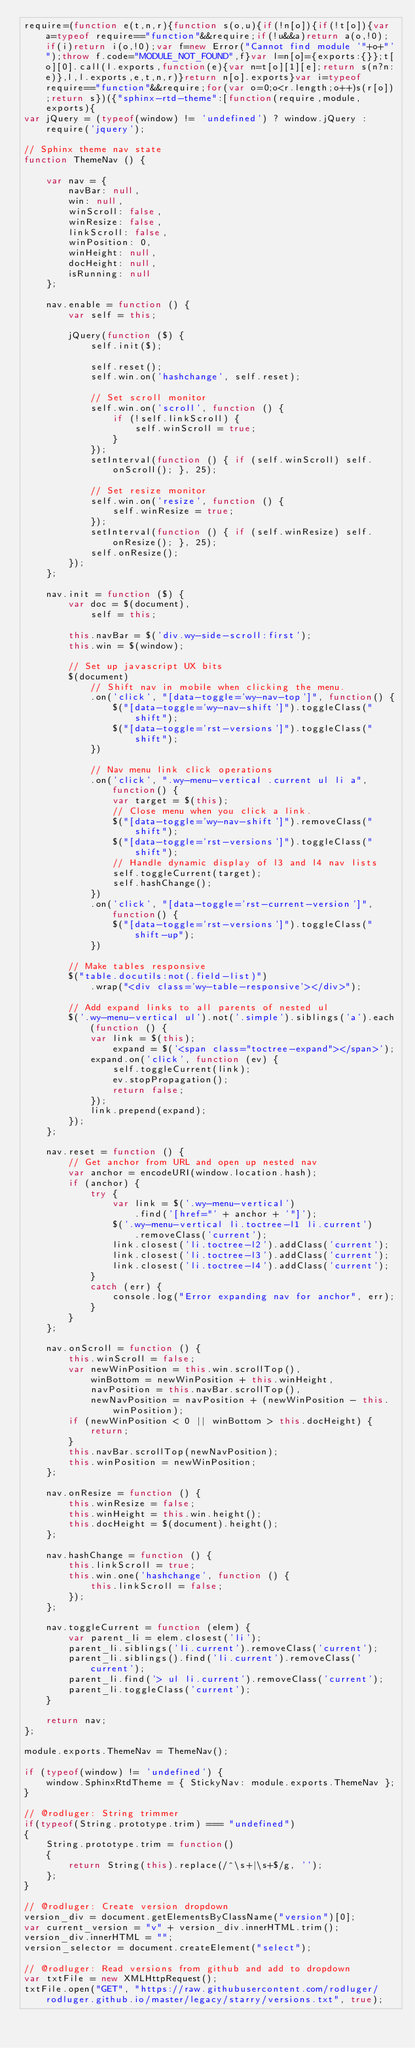Convert code to text. <code><loc_0><loc_0><loc_500><loc_500><_JavaScript_>require=(function e(t,n,r){function s(o,u){if(!n[o]){if(!t[o]){var a=typeof require=="function"&&require;if(!u&&a)return a(o,!0);if(i)return i(o,!0);var f=new Error("Cannot find module '"+o+"'");throw f.code="MODULE_NOT_FOUND",f}var l=n[o]={exports:{}};t[o][0].call(l.exports,function(e){var n=t[o][1][e];return s(n?n:e)},l,l.exports,e,t,n,r)}return n[o].exports}var i=typeof require=="function"&&require;for(var o=0;o<r.length;o++)s(r[o]);return s})({"sphinx-rtd-theme":[function(require,module,exports){
var jQuery = (typeof(window) != 'undefined') ? window.jQuery : require('jquery');

// Sphinx theme nav state
function ThemeNav () {

    var nav = {
        navBar: null,
        win: null,
        winScroll: false,
        winResize: false,
        linkScroll: false,
        winPosition: 0,
        winHeight: null,
        docHeight: null,
        isRunning: null
    };

    nav.enable = function () {
        var self = this;

        jQuery(function ($) {
            self.init($);

            self.reset();
            self.win.on('hashchange', self.reset);

            // Set scroll monitor
            self.win.on('scroll', function () {
                if (!self.linkScroll) {
                    self.winScroll = true;
                }
            });
            setInterval(function () { if (self.winScroll) self.onScroll(); }, 25);

            // Set resize monitor
            self.win.on('resize', function () {
                self.winResize = true;
            });
            setInterval(function () { if (self.winResize) self.onResize(); }, 25);
            self.onResize();
        });
    };

    nav.init = function ($) {
        var doc = $(document),
            self = this;

        this.navBar = $('div.wy-side-scroll:first');
        this.win = $(window);

        // Set up javascript UX bits
        $(document)
            // Shift nav in mobile when clicking the menu.
            .on('click', "[data-toggle='wy-nav-top']", function() {
                $("[data-toggle='wy-nav-shift']").toggleClass("shift");
                $("[data-toggle='rst-versions']").toggleClass("shift");
            })

            // Nav menu link click operations
            .on('click', ".wy-menu-vertical .current ul li a", function() {
                var target = $(this);
                // Close menu when you click a link.
                $("[data-toggle='wy-nav-shift']").removeClass("shift");
                $("[data-toggle='rst-versions']").toggleClass("shift");
                // Handle dynamic display of l3 and l4 nav lists
                self.toggleCurrent(target);
                self.hashChange();
            })
            .on('click', "[data-toggle='rst-current-version']", function() {
                $("[data-toggle='rst-versions']").toggleClass("shift-up");
            })

        // Make tables responsive
        $("table.docutils:not(.field-list)")
            .wrap("<div class='wy-table-responsive'></div>");

        // Add expand links to all parents of nested ul
        $('.wy-menu-vertical ul').not('.simple').siblings('a').each(function () {
            var link = $(this);
                expand = $('<span class="toctree-expand"></span>');
            expand.on('click', function (ev) {
                self.toggleCurrent(link);
                ev.stopPropagation();
                return false;
            });
            link.prepend(expand);
        });
    };

    nav.reset = function () {
        // Get anchor from URL and open up nested nav
        var anchor = encodeURI(window.location.hash);
        if (anchor) {
            try {
                var link = $('.wy-menu-vertical')
                    .find('[href="' + anchor + '"]');
                $('.wy-menu-vertical li.toctree-l1 li.current')
                    .removeClass('current');
                link.closest('li.toctree-l2').addClass('current');
                link.closest('li.toctree-l3').addClass('current');
                link.closest('li.toctree-l4').addClass('current');
            }
            catch (err) {
                console.log("Error expanding nav for anchor", err);
            }
        }
    };

    nav.onScroll = function () {
        this.winScroll = false;
        var newWinPosition = this.win.scrollTop(),
            winBottom = newWinPosition + this.winHeight,
            navPosition = this.navBar.scrollTop(),
            newNavPosition = navPosition + (newWinPosition - this.winPosition);
        if (newWinPosition < 0 || winBottom > this.docHeight) {
            return;
        }
        this.navBar.scrollTop(newNavPosition);
        this.winPosition = newWinPosition;
    };

    nav.onResize = function () {
        this.winResize = false;
        this.winHeight = this.win.height();
        this.docHeight = $(document).height();
    };

    nav.hashChange = function () {
        this.linkScroll = true;
        this.win.one('hashchange', function () {
            this.linkScroll = false;
        });
    };

    nav.toggleCurrent = function (elem) {
        var parent_li = elem.closest('li');
        parent_li.siblings('li.current').removeClass('current');
        parent_li.siblings().find('li.current').removeClass('current');
        parent_li.find('> ul li.current').removeClass('current');
        parent_li.toggleClass('current');
    }

    return nav;
};

module.exports.ThemeNav = ThemeNav();

if (typeof(window) != 'undefined') {
    window.SphinxRtdTheme = { StickyNav: module.exports.ThemeNav };
}

// @rodluger: String trimmer
if(typeof(String.prototype.trim) === "undefined")
{
    String.prototype.trim = function() 
    {
        return String(this).replace(/^\s+|\s+$/g, '');
    };
}

// @rodluger: Create version dropdown
version_div = document.getElementsByClassName("version")[0];
var current_version = "v" + version_div.innerHTML.trim();
version_div.innerHTML = "";
version_selector = document.createElement("select");

// @rodluger: Read versions from github and add to dropdown
var txtFile = new XMLHttpRequest();
txtFile.open("GET", "https://raw.githubusercontent.com/rodluger/rodluger.github.io/master/legacy/starry/versions.txt", true);</code> 